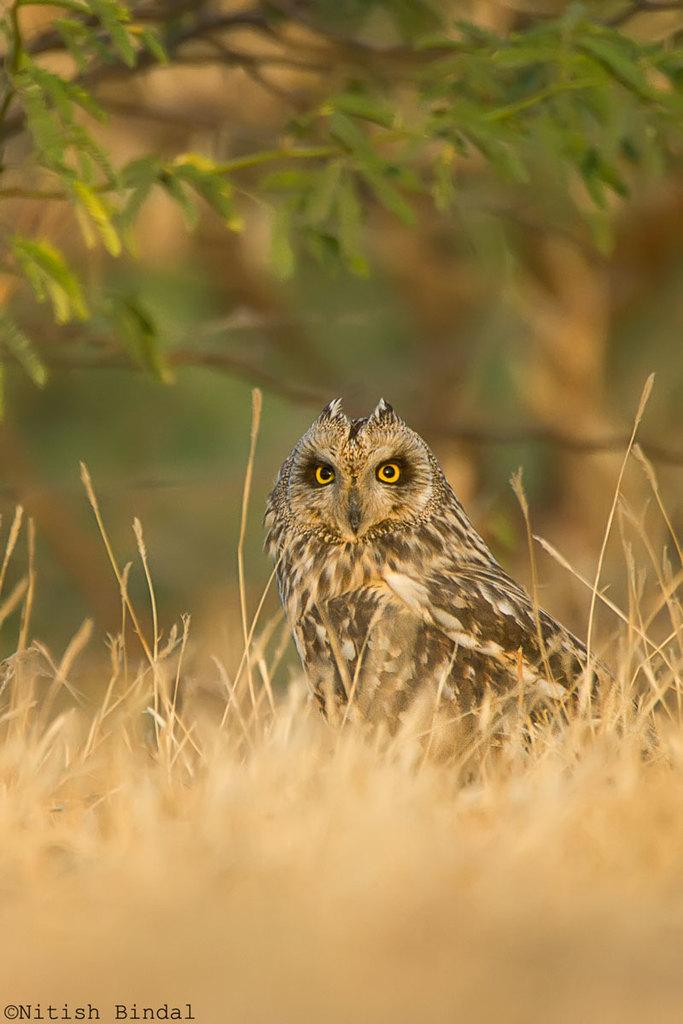Where was the image taken? The image was taken outdoors. What type of ground is visible in the image? There is a ground with grass in the image. What animal is in the middle of the image? There is an owl in the middle of the image. What can be seen in the background of the image? There is a tree in the background of the image. What is the topic of the heated discussion happening at the edge of the image? There is no discussion happening in the image, and therefore no topic or heated emotions can be observed. 